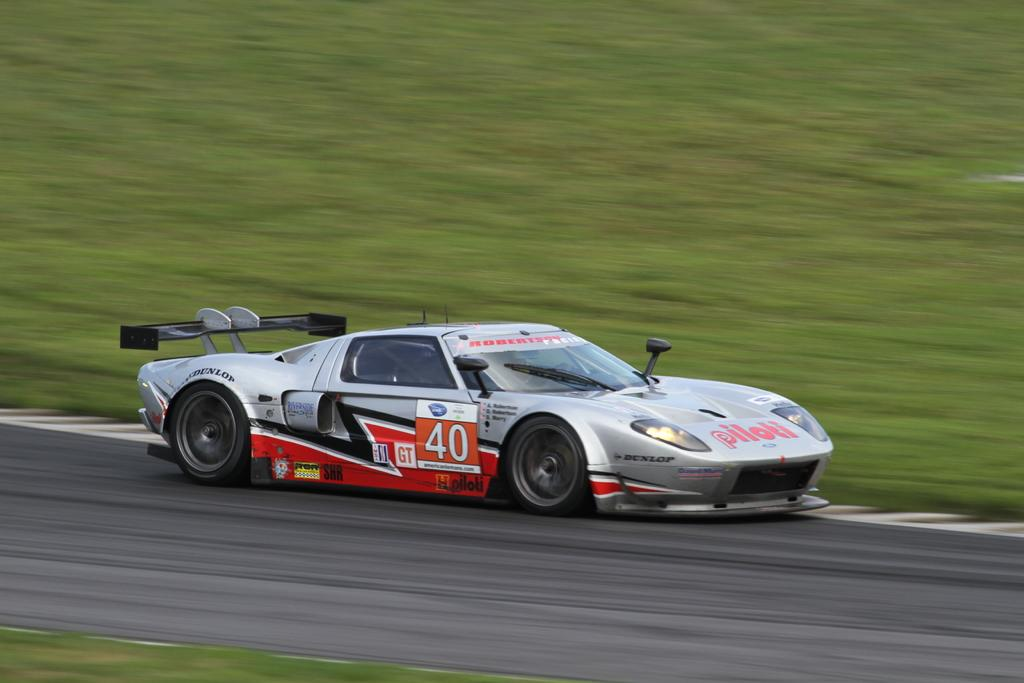What type of vehicle is in the image? There is a sports car in the image. What is the sports car doing in the image? The sports car is moving on the road. What color is the sports car? The sports car is silver in color. What type of terrain can be seen in the image? There is grass visible in the image. How many crates of lettuce are being transported by the sports car in the image? There are no crates of lettuce present in the image; it only features a silver sports car moving on the road. 